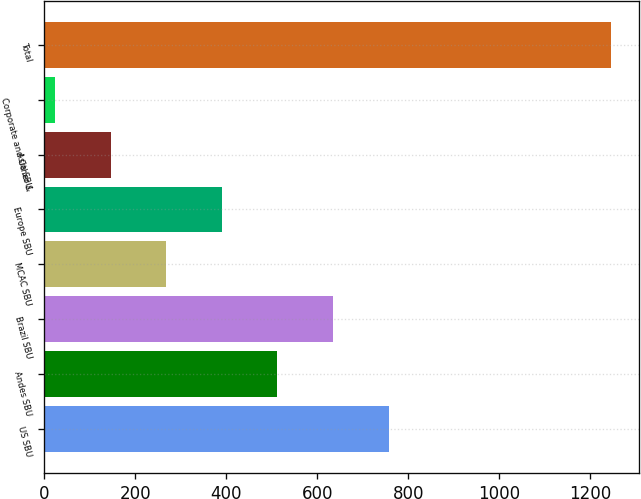<chart> <loc_0><loc_0><loc_500><loc_500><bar_chart><fcel>US SBU<fcel>Andes SBU<fcel>Brazil SBU<fcel>MCAC SBU<fcel>Europe SBU<fcel>Asia SBU<fcel>Corporate and Other &<fcel>Total<nl><fcel>756.6<fcel>512.4<fcel>634.5<fcel>268.2<fcel>390.3<fcel>146.1<fcel>24<fcel>1245<nl></chart> 